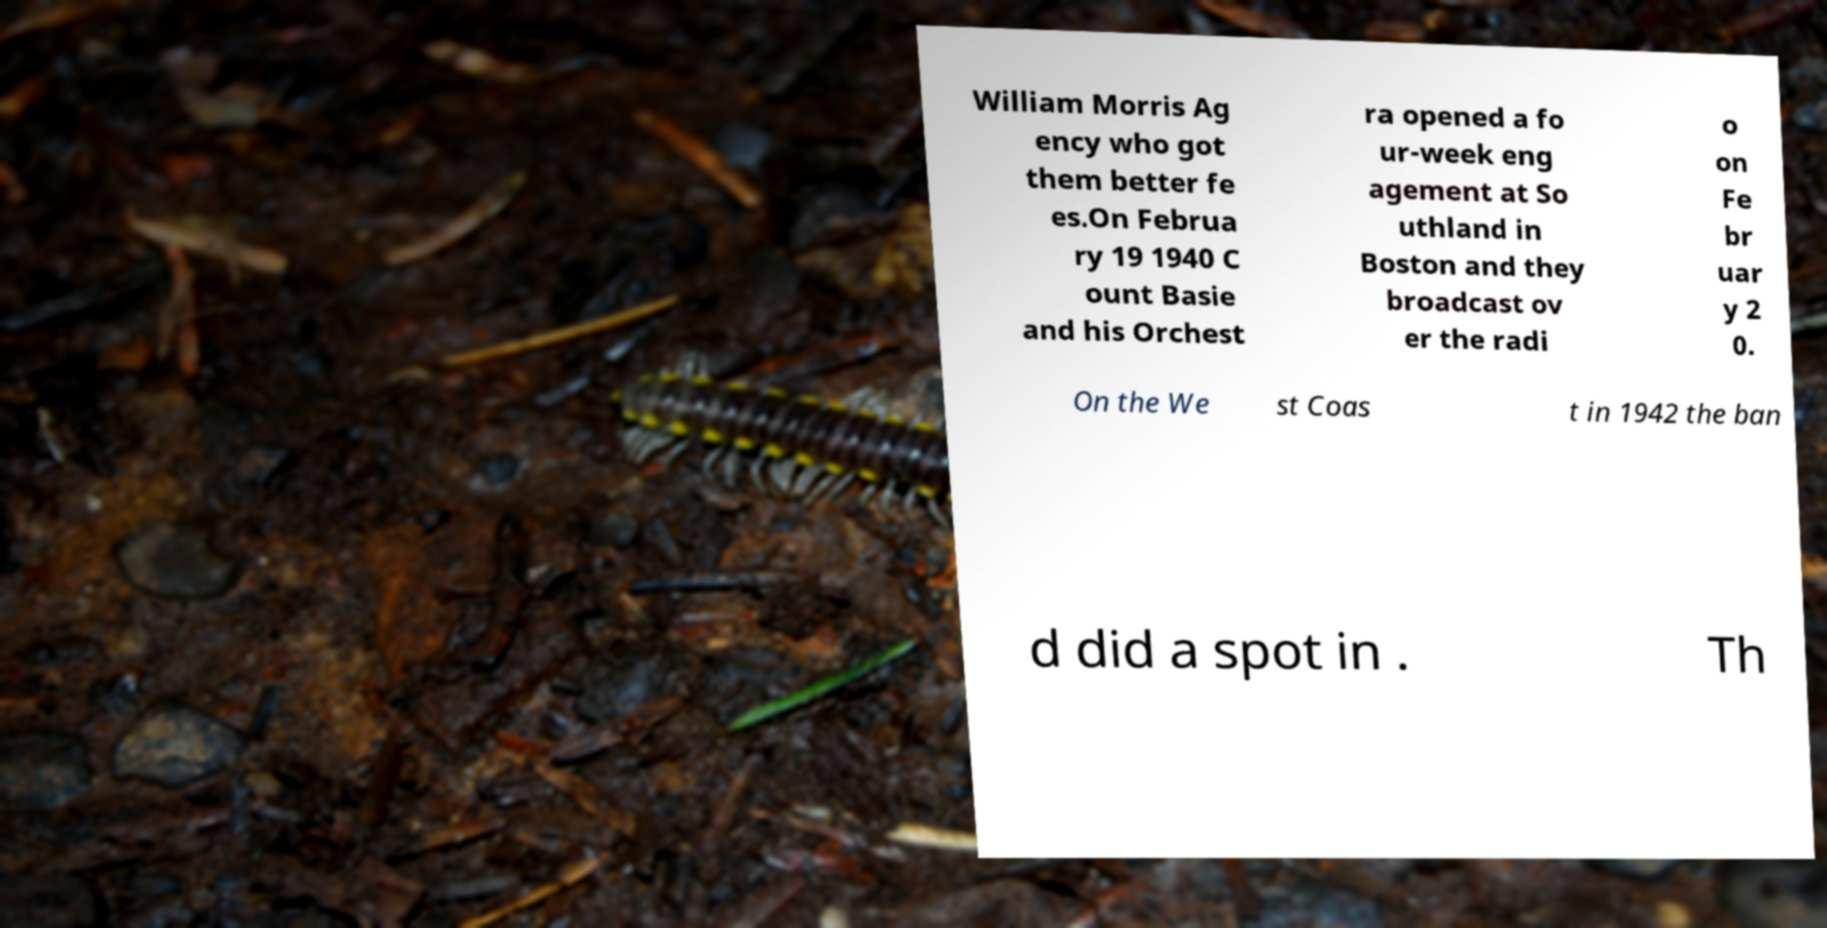Please read and relay the text visible in this image. What does it say? William Morris Ag ency who got them better fe es.On Februa ry 19 1940 C ount Basie and his Orchest ra opened a fo ur-week eng agement at So uthland in Boston and they broadcast ov er the radi o on Fe br uar y 2 0. On the We st Coas t in 1942 the ban d did a spot in . Th 